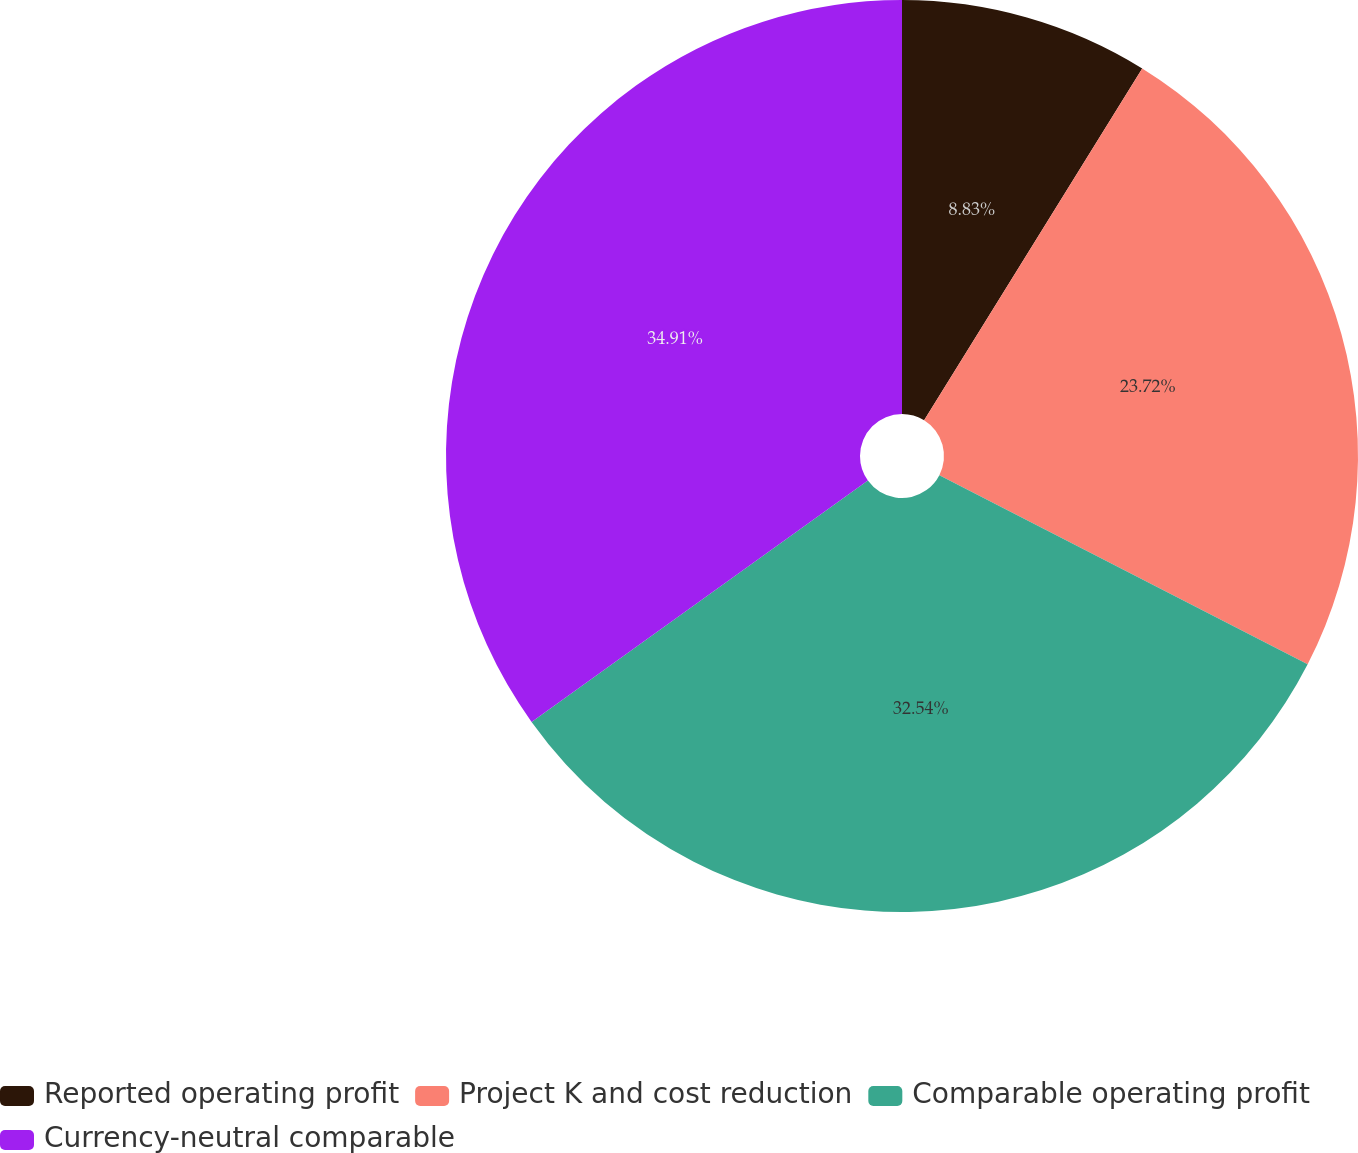Convert chart. <chart><loc_0><loc_0><loc_500><loc_500><pie_chart><fcel>Reported operating profit<fcel>Project K and cost reduction<fcel>Comparable operating profit<fcel>Currency-neutral comparable<nl><fcel>8.83%<fcel>23.72%<fcel>32.54%<fcel>34.91%<nl></chart> 